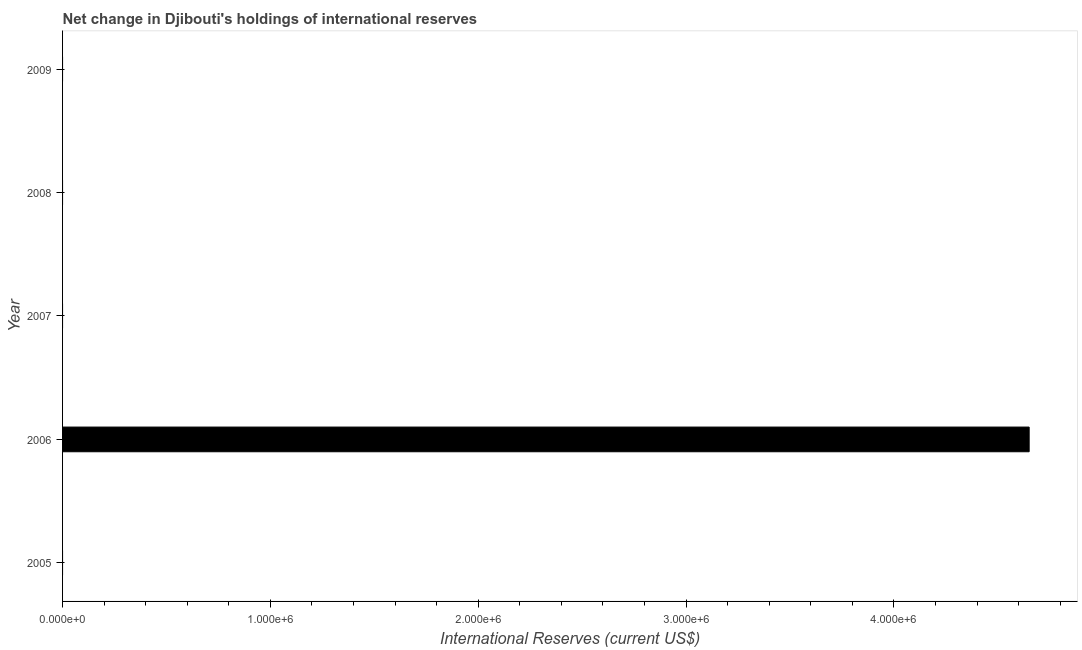What is the title of the graph?
Make the answer very short. Net change in Djibouti's holdings of international reserves. What is the label or title of the X-axis?
Offer a very short reply. International Reserves (current US$). What is the label or title of the Y-axis?
Keep it short and to the point. Year. Across all years, what is the maximum reserves and related items?
Your answer should be compact. 4.65e+06. What is the sum of the reserves and related items?
Provide a short and direct response. 4.65e+06. What is the average reserves and related items per year?
Provide a short and direct response. 9.30e+05. What is the median reserves and related items?
Your response must be concise. 0. In how many years, is the reserves and related items greater than 1600000 US$?
Your answer should be compact. 1. What is the difference between the highest and the lowest reserves and related items?
Your response must be concise. 4.65e+06. Are all the bars in the graph horizontal?
Ensure brevity in your answer.  Yes. How many years are there in the graph?
Give a very brief answer. 5. What is the difference between two consecutive major ticks on the X-axis?
Offer a very short reply. 1.00e+06. Are the values on the major ticks of X-axis written in scientific E-notation?
Provide a succinct answer. Yes. What is the International Reserves (current US$) in 2006?
Your answer should be compact. 4.65e+06. What is the International Reserves (current US$) of 2008?
Keep it short and to the point. 0. 